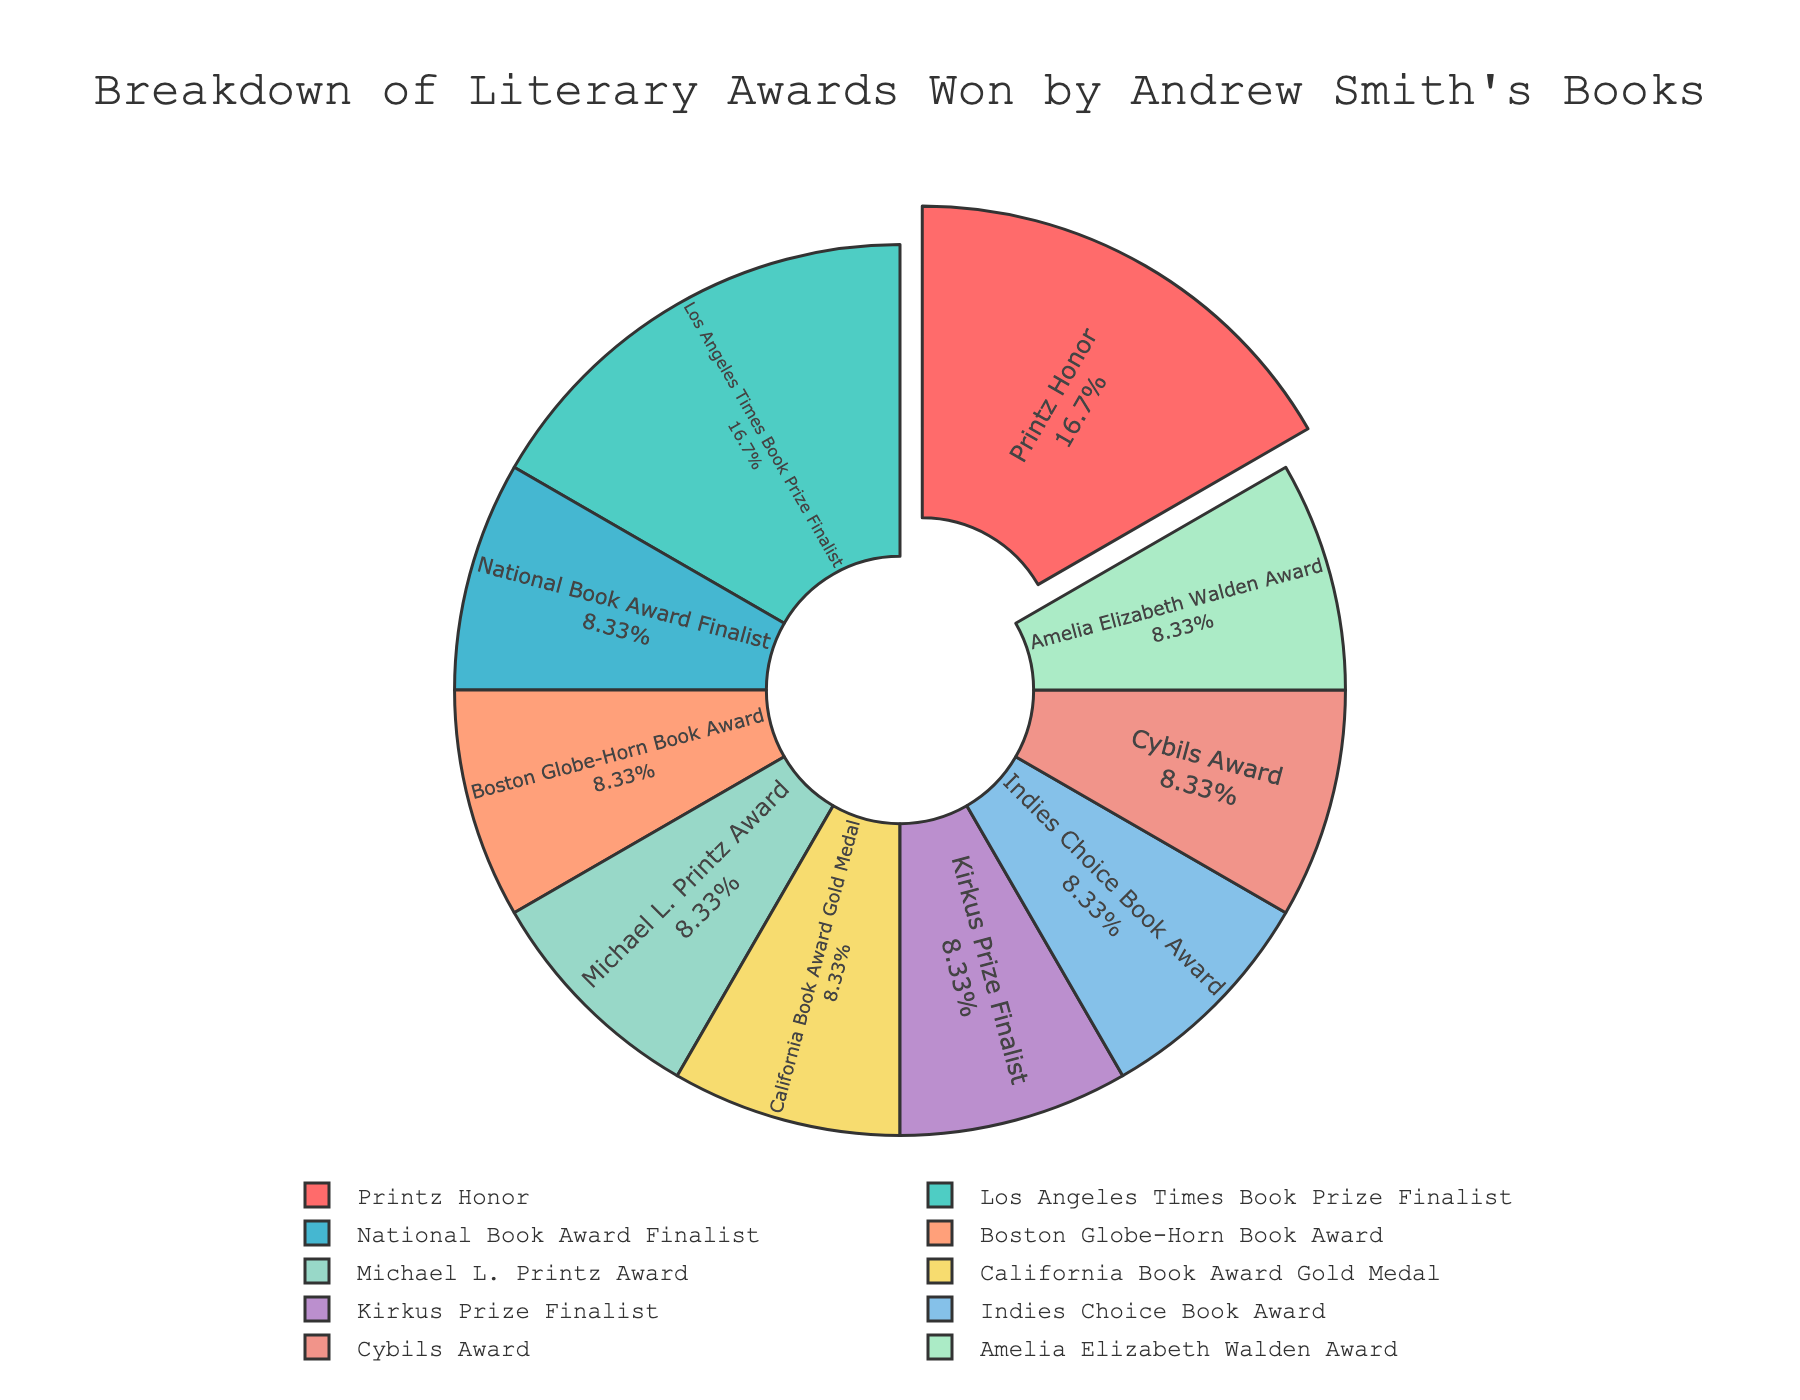What's the total number of awards won by Andrew Smith's books? First, identify the number of wins for each award from the chart. Sum them up: 2 (Printz Honor) + 1 (National Book Award Finalist) + 1 (Boston Globe-Horn Book Award) + 1 (Michael L. Printz Award) + 1 (California Book Award Gold Medal) + 2 (Los Angeles Times Book Prize Finalist) + 1 (Kirkus Prize Finalist) + 1 (Indies Choice Book Award) + 1 (Cybils Award) + 1 (Amelia Elizabeth Walden Award). Total: 12
Answer: 12 Which award categories have the same number of wins, and what are they? By looking at the pie chart, observe that Printz Honor and Los Angeles Times Book Prize Finalist both have 2 wins each. The rest of the categories have only 1 win each.
Answer: Printz Honor, Los Angeles Times Book Prize Finalist Which award has the highest number of wins and how many wins does it have? Identify the largest segment in the pie chart, which is for the 'Printz Honor' award with 2 wins.
Answer: Printz Honor, 2 How much larger is the piece of the pie representing the Printz Honor than the piece representing the Boston Globe-Horn Book Award? The Printz Honor has 2 wins and the Boston Globe-Horn Book Award has 1 win. The difference is 2 - 1 = 1.
Answer: 1 Calculate the percentage of total wins represented by the Los Angeles Times Book Prize Finalist category. Los Angeles Times Book Prize Finalist has 2 wins. The total number of wins is 12. The percentage is (2/12) * 100 which simplifies to approximately 16.67%.
Answer: 16.67% How many categories have only one win each? By reviewing the pie chart, count the segments that represent categories with only one win each: National Book Award Finalist, Boston Globe-Horn Book Award, Michael L. Printz Award, California Book Award Gold Medal, Kirkus Prize Finalist, Indies Choice Book Award, Cybils Award, Amelia Elizabeth Walden Award. There are 8 categories in total.
Answer: 8 Which color represents the Michael L. Printz Award in the pie chart, and how can you identify it? The Michael L. Printz Award slice can be identified both by its position and by referring to the legend where the award names are color-coded. The actual color in the plot visual should match the one explained as representing the Michael L. Printz Award.
Answer: color should be identified from the legend If the chart were to be adjusted so that each slice were exactly equal, how many wins would each award have? If there are 10 award categories and the total number of wins is 12, each award category would theoretically have 12/10 = 1.2 wins in an even distribution.
Answer: 1.2 What is the combined percentage of total wins for Printz Honor and Los Angeles Times Book Prize Finalist categories? Printz Honor has 2 wins and Los Angeles Times Book Prize Finalist has 2 wins. Total wins are 12. Combined, they have 4 wins, which is (4/12) * 100 = 33.33%.
Answer: 33.33% 